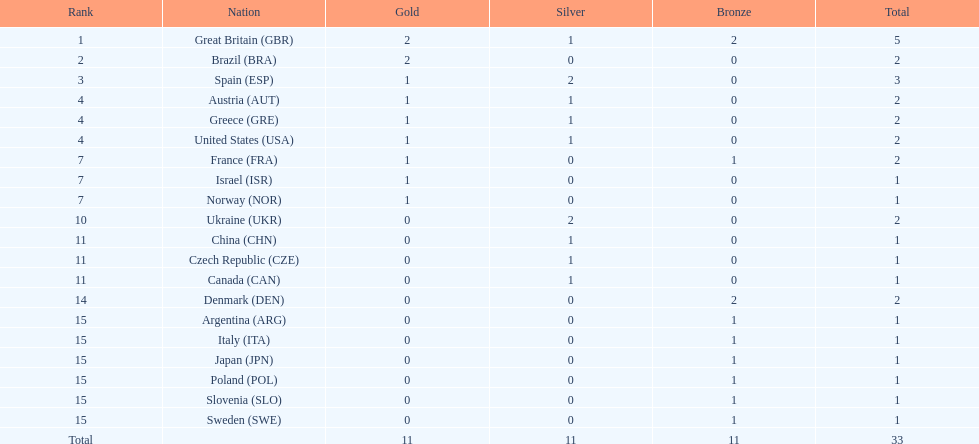What is the overall count of medals secured by the united states? 2. 